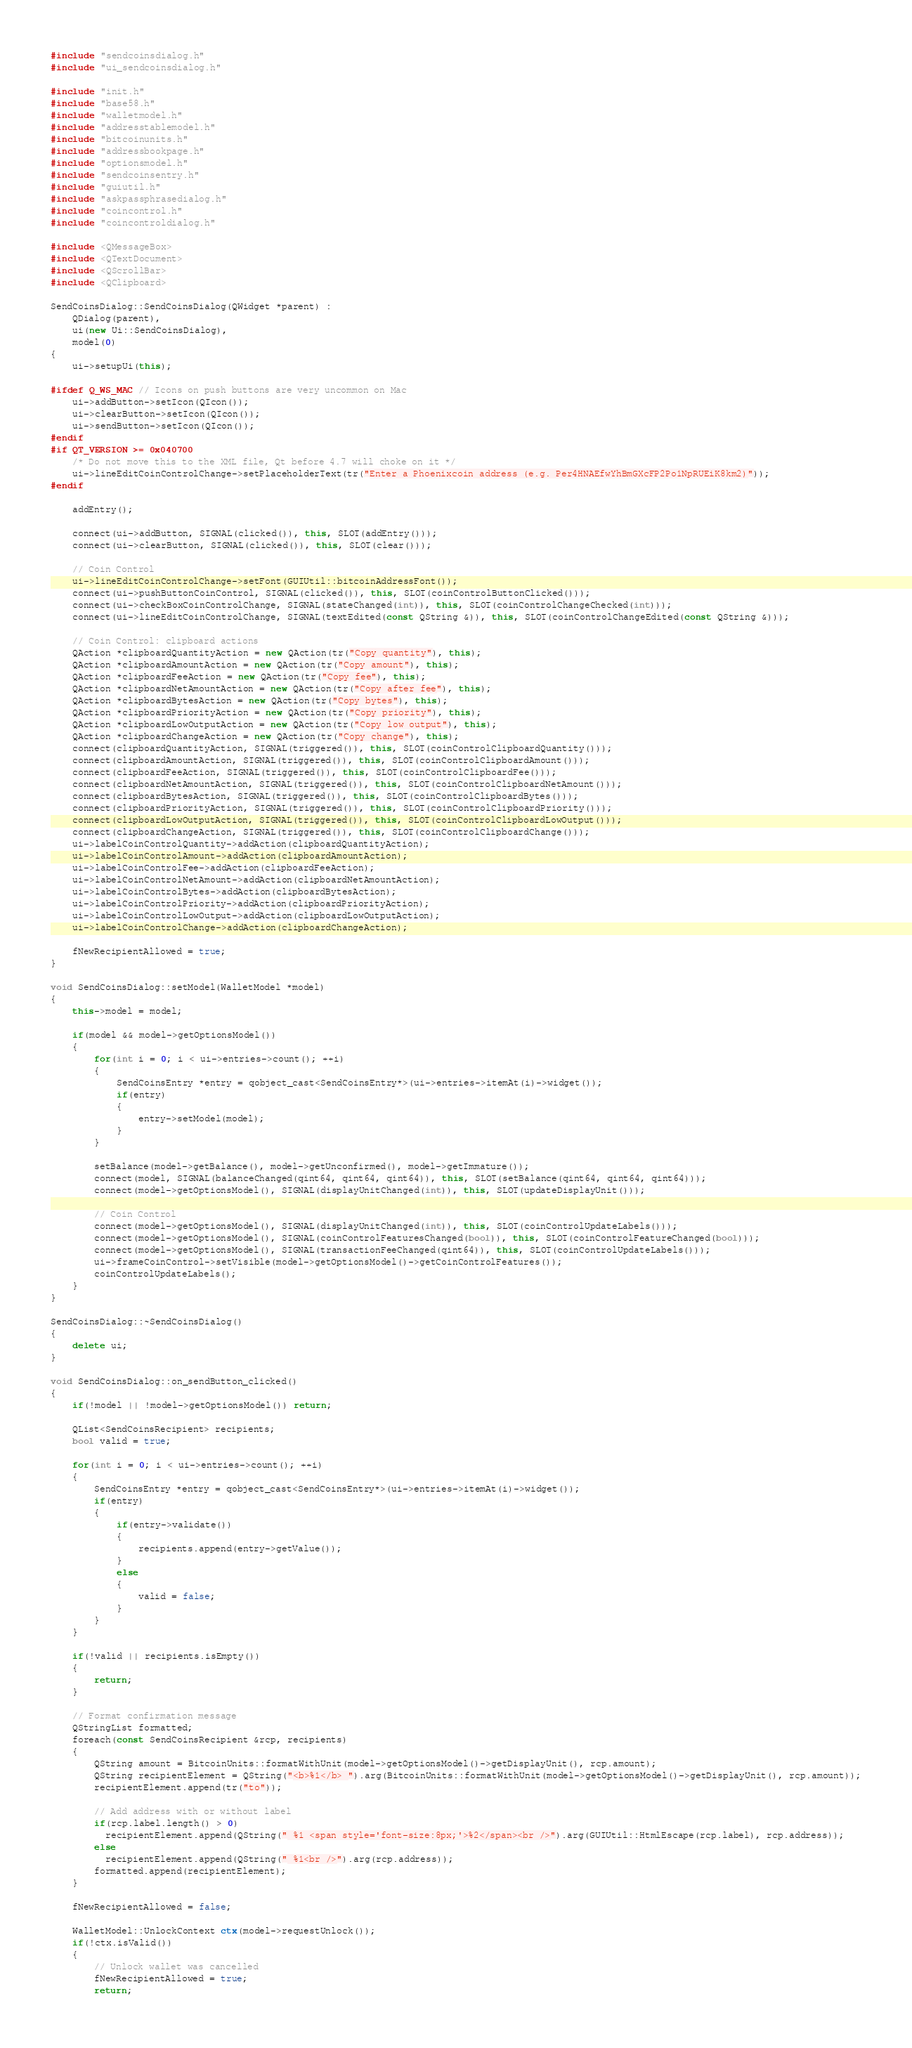<code> <loc_0><loc_0><loc_500><loc_500><_C++_>#include "sendcoinsdialog.h"
#include "ui_sendcoinsdialog.h"

#include "init.h"
#include "base58.h"
#include "walletmodel.h"
#include "addresstablemodel.h"
#include "bitcoinunits.h"
#include "addressbookpage.h"
#include "optionsmodel.h"
#include "sendcoinsentry.h"
#include "guiutil.h"
#include "askpassphrasedialog.h"
#include "coincontrol.h"
#include "coincontroldialog.h"

#include <QMessageBox>
#include <QTextDocument>
#include <QScrollBar>
#include <QClipboard>

SendCoinsDialog::SendCoinsDialog(QWidget *parent) :
    QDialog(parent),
    ui(new Ui::SendCoinsDialog),
    model(0)
{
    ui->setupUi(this);

#ifdef Q_WS_MAC // Icons on push buttons are very uncommon on Mac
    ui->addButton->setIcon(QIcon());
    ui->clearButton->setIcon(QIcon());
    ui->sendButton->setIcon(QIcon());
#endif
#if QT_VERSION >= 0x040700
    /* Do not move this to the XML file, Qt before 4.7 will choke on it */
    ui->lineEditCoinControlChange->setPlaceholderText(tr("Enter a Phoenixcoin address (e.g. Per4HNAEfwYhBmGXcFP2Po1NpRUEiK8km2)"));
#endif

    addEntry();

    connect(ui->addButton, SIGNAL(clicked()), this, SLOT(addEntry()));
    connect(ui->clearButton, SIGNAL(clicked()), this, SLOT(clear()));

    // Coin Control
    ui->lineEditCoinControlChange->setFont(GUIUtil::bitcoinAddressFont());
    connect(ui->pushButtonCoinControl, SIGNAL(clicked()), this, SLOT(coinControlButtonClicked()));
    connect(ui->checkBoxCoinControlChange, SIGNAL(stateChanged(int)), this, SLOT(coinControlChangeChecked(int)));
    connect(ui->lineEditCoinControlChange, SIGNAL(textEdited(const QString &)), this, SLOT(coinControlChangeEdited(const QString &)));

    // Coin Control: clipboard actions
    QAction *clipboardQuantityAction = new QAction(tr("Copy quantity"), this);
    QAction *clipboardAmountAction = new QAction(tr("Copy amount"), this);
    QAction *clipboardFeeAction = new QAction(tr("Copy fee"), this);
    QAction *clipboardNetAmountAction = new QAction(tr("Copy after fee"), this);
    QAction *clipboardBytesAction = new QAction(tr("Copy bytes"), this);
    QAction *clipboardPriorityAction = new QAction(tr("Copy priority"), this);
    QAction *clipboardLowOutputAction = new QAction(tr("Copy low output"), this);
    QAction *clipboardChangeAction = new QAction(tr("Copy change"), this);
    connect(clipboardQuantityAction, SIGNAL(triggered()), this, SLOT(coinControlClipboardQuantity()));
    connect(clipboardAmountAction, SIGNAL(triggered()), this, SLOT(coinControlClipboardAmount()));
    connect(clipboardFeeAction, SIGNAL(triggered()), this, SLOT(coinControlClipboardFee()));
    connect(clipboardNetAmountAction, SIGNAL(triggered()), this, SLOT(coinControlClipboardNetAmount()));
    connect(clipboardBytesAction, SIGNAL(triggered()), this, SLOT(coinControlClipboardBytes()));
    connect(clipboardPriorityAction, SIGNAL(triggered()), this, SLOT(coinControlClipboardPriority()));
    connect(clipboardLowOutputAction, SIGNAL(triggered()), this, SLOT(coinControlClipboardLowOutput()));
    connect(clipboardChangeAction, SIGNAL(triggered()), this, SLOT(coinControlClipboardChange()));
    ui->labelCoinControlQuantity->addAction(clipboardQuantityAction);
    ui->labelCoinControlAmount->addAction(clipboardAmountAction);
    ui->labelCoinControlFee->addAction(clipboardFeeAction);
    ui->labelCoinControlNetAmount->addAction(clipboardNetAmountAction);
    ui->labelCoinControlBytes->addAction(clipboardBytesAction);
    ui->labelCoinControlPriority->addAction(clipboardPriorityAction);
    ui->labelCoinControlLowOutput->addAction(clipboardLowOutputAction);
    ui->labelCoinControlChange->addAction(clipboardChangeAction);

    fNewRecipientAllowed = true;
}

void SendCoinsDialog::setModel(WalletModel *model)
{
    this->model = model;

    if(model && model->getOptionsModel())
    {
        for(int i = 0; i < ui->entries->count(); ++i)
        {
            SendCoinsEntry *entry = qobject_cast<SendCoinsEntry*>(ui->entries->itemAt(i)->widget());
            if(entry)
            {
                entry->setModel(model);
            }
        }

        setBalance(model->getBalance(), model->getUnconfirmed(), model->getImmature());
        connect(model, SIGNAL(balanceChanged(qint64, qint64, qint64)), this, SLOT(setBalance(qint64, qint64, qint64)));
        connect(model->getOptionsModel(), SIGNAL(displayUnitChanged(int)), this, SLOT(updateDisplayUnit()));

        // Coin Control
        connect(model->getOptionsModel(), SIGNAL(displayUnitChanged(int)), this, SLOT(coinControlUpdateLabels()));
        connect(model->getOptionsModel(), SIGNAL(coinControlFeaturesChanged(bool)), this, SLOT(coinControlFeatureChanged(bool)));
        connect(model->getOptionsModel(), SIGNAL(transactionFeeChanged(qint64)), this, SLOT(coinControlUpdateLabels()));
        ui->frameCoinControl->setVisible(model->getOptionsModel()->getCoinControlFeatures());
        coinControlUpdateLabels();
    }
}

SendCoinsDialog::~SendCoinsDialog()
{
    delete ui;
}

void SendCoinsDialog::on_sendButton_clicked()
{
    if(!model || !model->getOptionsModel()) return;

    QList<SendCoinsRecipient> recipients;
    bool valid = true;

    for(int i = 0; i < ui->entries->count(); ++i)
    {
        SendCoinsEntry *entry = qobject_cast<SendCoinsEntry*>(ui->entries->itemAt(i)->widget());
        if(entry)
        {
            if(entry->validate())
            {
                recipients.append(entry->getValue());
            }
            else
            {
                valid = false;
            }
        }
    }

    if(!valid || recipients.isEmpty())
    {
        return;
    }

    // Format confirmation message
    QStringList formatted;
    foreach(const SendCoinsRecipient &rcp, recipients)
    {
        QString amount = BitcoinUnits::formatWithUnit(model->getOptionsModel()->getDisplayUnit(), rcp.amount);
        QString recipientElement = QString("<b>%1</b> ").arg(BitcoinUnits::formatWithUnit(model->getOptionsModel()->getDisplayUnit(), rcp.amount));
        recipientElement.append(tr("to"));

        // Add address with or without label
        if(rcp.label.length() > 0)
          recipientElement.append(QString(" %1 <span style='font-size:8px;'>%2</span><br />").arg(GUIUtil::HtmlEscape(rcp.label), rcp.address));
        else
          recipientElement.append(QString(" %1<br />").arg(rcp.address));
        formatted.append(recipientElement);
    }

    fNewRecipientAllowed = false;

    WalletModel::UnlockContext ctx(model->requestUnlock());
    if(!ctx.isValid())
    {
        // Unlock wallet was cancelled
        fNewRecipientAllowed = true;
        return;</code> 